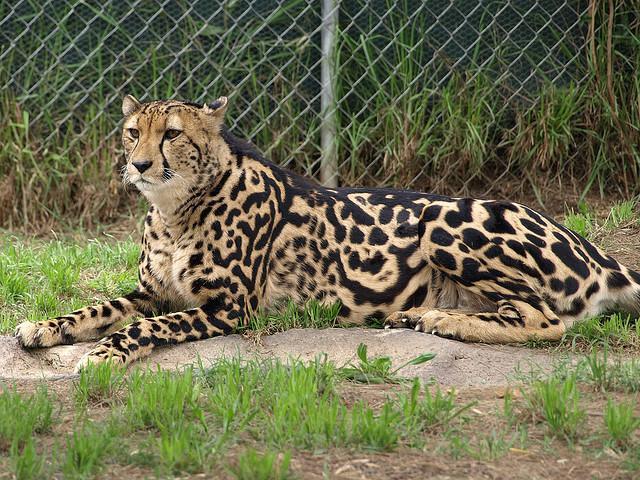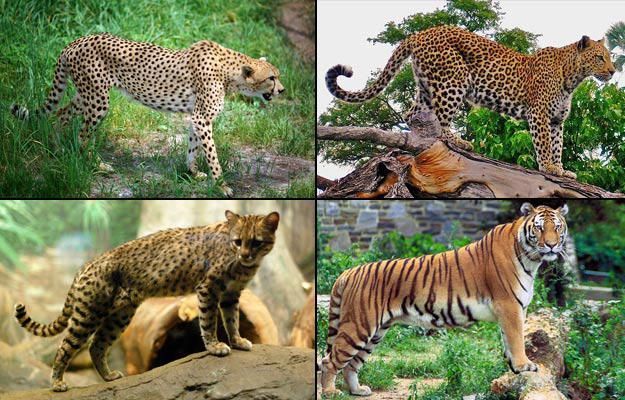The first image is the image on the left, the second image is the image on the right. For the images displayed, is the sentence "At least one of the animals is movie fast." factually correct? Answer yes or no. No. The first image is the image on the left, the second image is the image on the right. Evaluate the accuracy of this statement regarding the images: "The left image contains at least three spotted wild cats.". Is it true? Answer yes or no. No. 